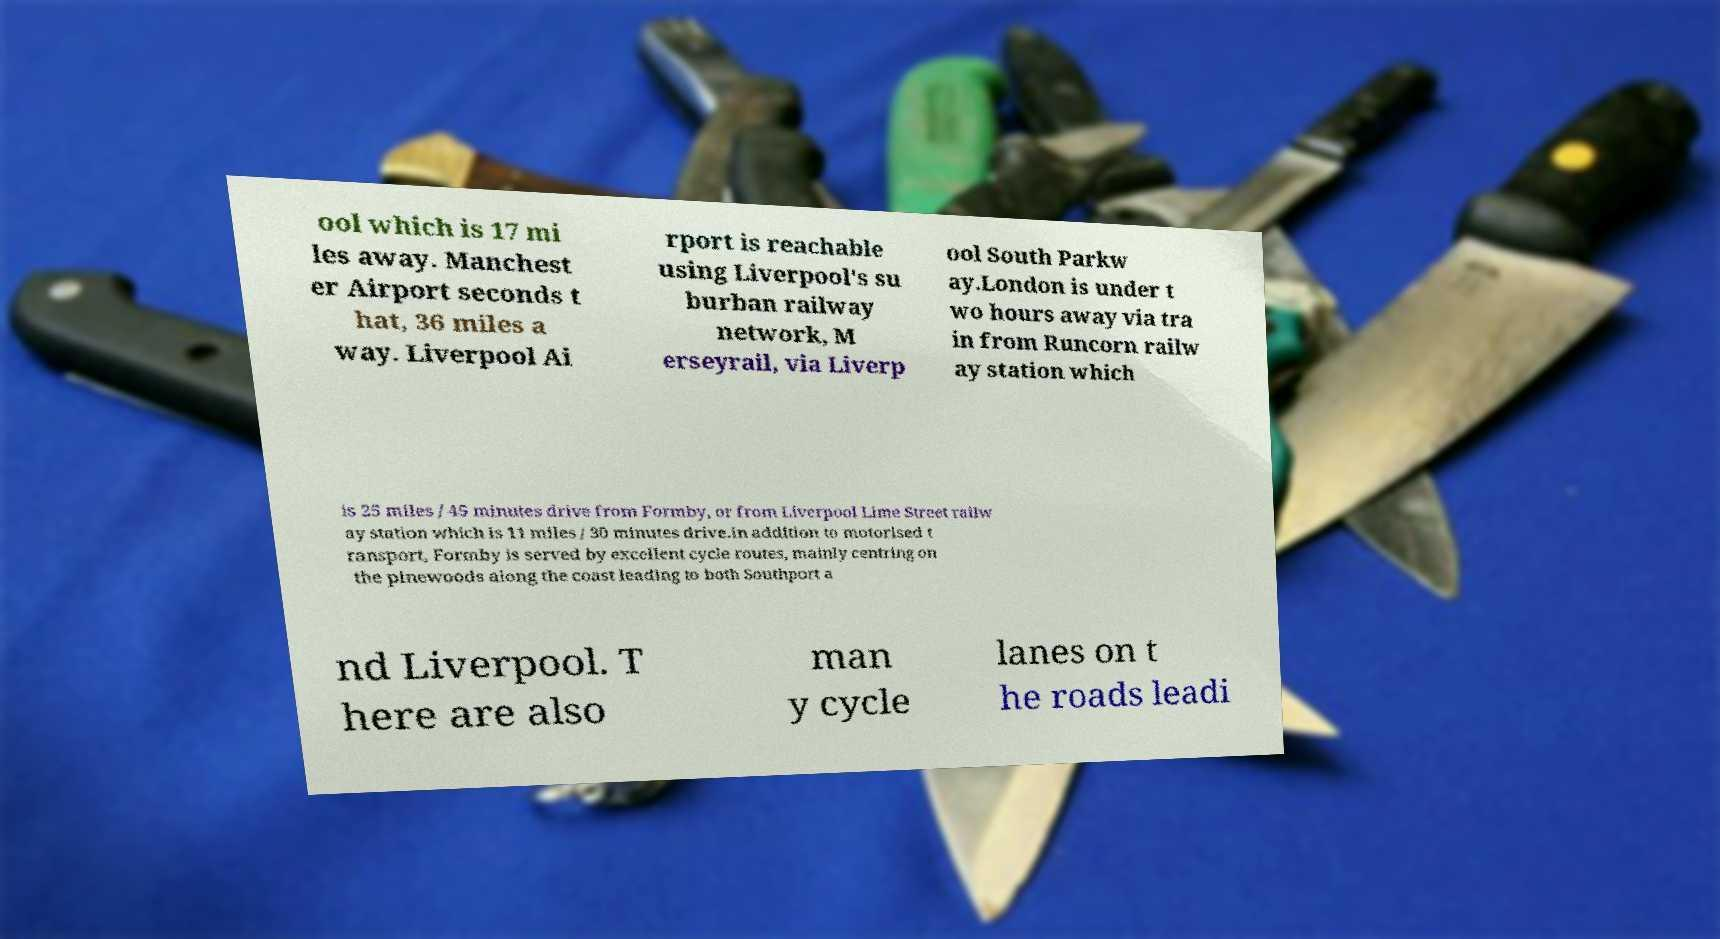Please read and relay the text visible in this image. What does it say? ool which is 17 mi les away. Manchest er Airport seconds t hat, 36 miles a way. Liverpool Ai rport is reachable using Liverpool's su burban railway network, M erseyrail, via Liverp ool South Parkw ay.London is under t wo hours away via tra in from Runcorn railw ay station which is 25 miles / 45 minutes drive from Formby, or from Liverpool Lime Street railw ay station which is 11 miles / 30 minutes drive.In addition to motorised t ransport, Formby is served by excellent cycle routes, mainly centring on the pinewoods along the coast leading to both Southport a nd Liverpool. T here are also man y cycle lanes on t he roads leadi 